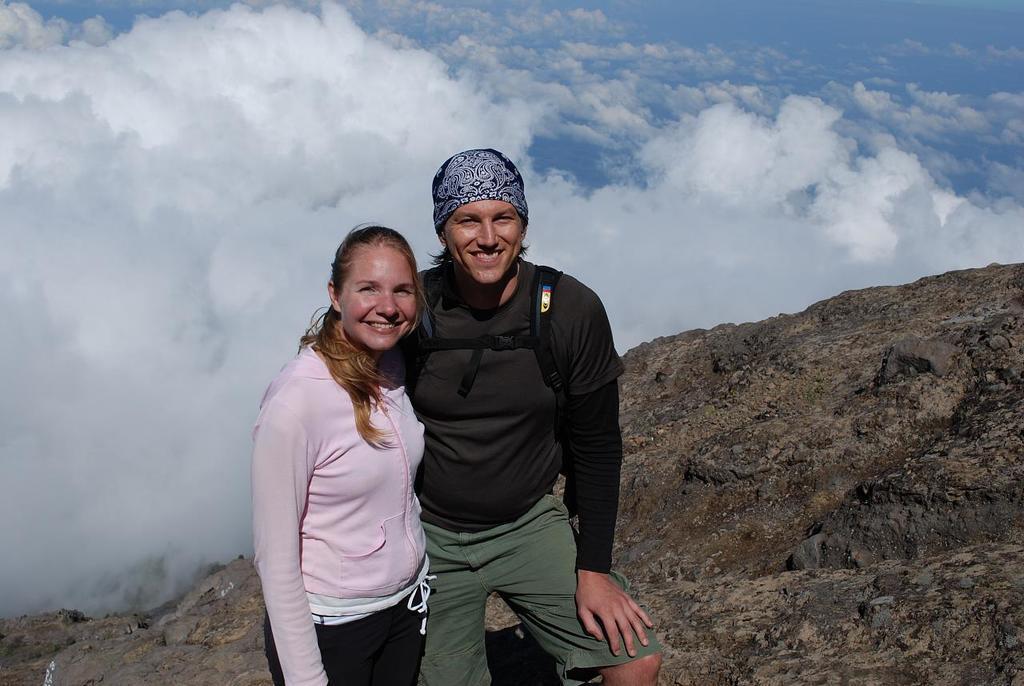In one or two sentences, can you explain what this image depicts? In the image we can see there are clouds in the sky and two people are standing on the rock hill, one woman and a man. Woman is wearing a pink colour jacket and man is wearing black shirt and man is also wearing a cap. 